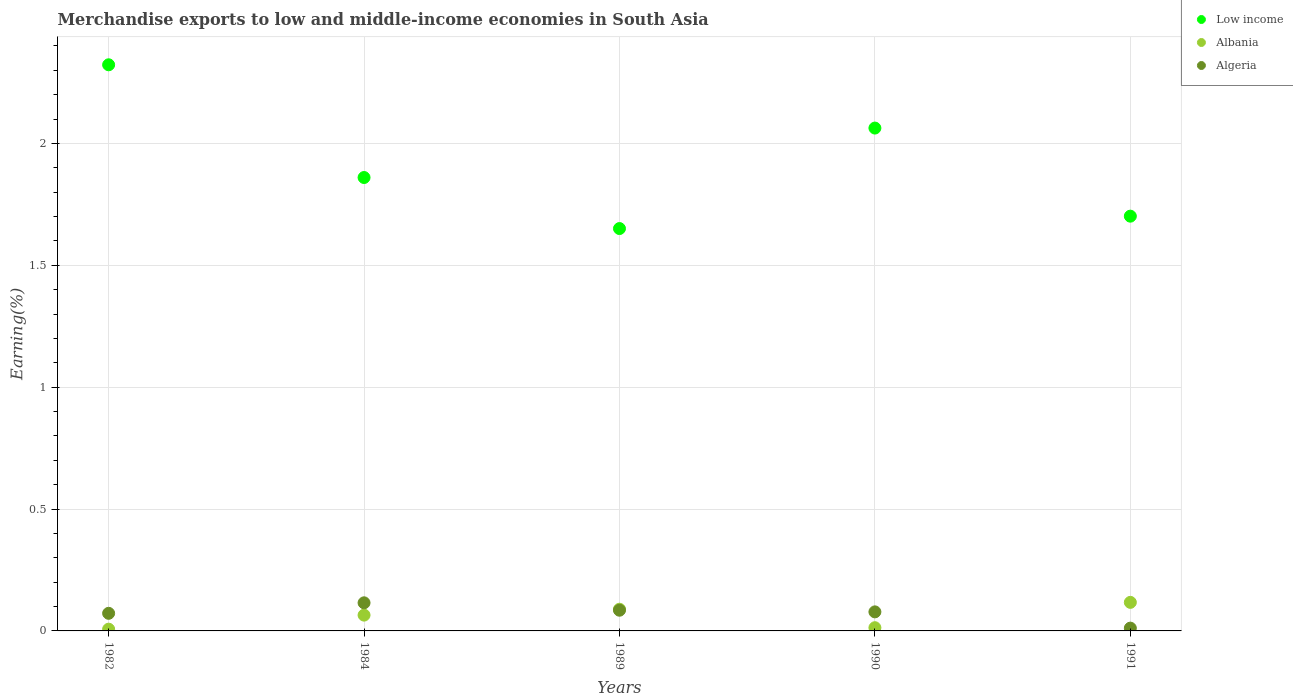How many different coloured dotlines are there?
Offer a very short reply. 3. Is the number of dotlines equal to the number of legend labels?
Make the answer very short. Yes. What is the percentage of amount earned from merchandise exports in Algeria in 1982?
Your response must be concise. 0.07. Across all years, what is the maximum percentage of amount earned from merchandise exports in Low income?
Provide a short and direct response. 2.32. Across all years, what is the minimum percentage of amount earned from merchandise exports in Albania?
Provide a succinct answer. 0.01. In which year was the percentage of amount earned from merchandise exports in Low income minimum?
Your answer should be compact. 1989. What is the total percentage of amount earned from merchandise exports in Albania in the graph?
Keep it short and to the point. 0.29. What is the difference between the percentage of amount earned from merchandise exports in Albania in 1989 and that in 1991?
Provide a short and direct response. -0.03. What is the difference between the percentage of amount earned from merchandise exports in Algeria in 1990 and the percentage of amount earned from merchandise exports in Albania in 1982?
Offer a very short reply. 0.07. What is the average percentage of amount earned from merchandise exports in Algeria per year?
Provide a short and direct response. 0.07. In the year 1984, what is the difference between the percentage of amount earned from merchandise exports in Low income and percentage of amount earned from merchandise exports in Albania?
Your response must be concise. 1.8. In how many years, is the percentage of amount earned from merchandise exports in Algeria greater than 0.5 %?
Provide a short and direct response. 0. What is the ratio of the percentage of amount earned from merchandise exports in Albania in 1984 to that in 1991?
Offer a terse response. 0.55. Is the percentage of amount earned from merchandise exports in Albania in 1982 less than that in 1984?
Provide a succinct answer. Yes. Is the difference between the percentage of amount earned from merchandise exports in Low income in 1984 and 1991 greater than the difference between the percentage of amount earned from merchandise exports in Albania in 1984 and 1991?
Ensure brevity in your answer.  Yes. What is the difference between the highest and the second highest percentage of amount earned from merchandise exports in Low income?
Ensure brevity in your answer.  0.26. What is the difference between the highest and the lowest percentage of amount earned from merchandise exports in Low income?
Your response must be concise. 0.67. Is the sum of the percentage of amount earned from merchandise exports in Albania in 1982 and 1984 greater than the maximum percentage of amount earned from merchandise exports in Algeria across all years?
Your answer should be very brief. No. Is it the case that in every year, the sum of the percentage of amount earned from merchandise exports in Albania and percentage of amount earned from merchandise exports in Algeria  is greater than the percentage of amount earned from merchandise exports in Low income?
Provide a short and direct response. No. How many dotlines are there?
Your answer should be very brief. 3. How many years are there in the graph?
Offer a very short reply. 5. What is the difference between two consecutive major ticks on the Y-axis?
Make the answer very short. 0.5. Does the graph contain grids?
Keep it short and to the point. Yes. Where does the legend appear in the graph?
Make the answer very short. Top right. How many legend labels are there?
Your answer should be very brief. 3. How are the legend labels stacked?
Give a very brief answer. Vertical. What is the title of the graph?
Your response must be concise. Merchandise exports to low and middle-income economies in South Asia. Does "Lower middle income" appear as one of the legend labels in the graph?
Provide a succinct answer. No. What is the label or title of the Y-axis?
Give a very brief answer. Earning(%). What is the Earning(%) in Low income in 1982?
Your response must be concise. 2.32. What is the Earning(%) of Albania in 1982?
Give a very brief answer. 0.01. What is the Earning(%) of Algeria in 1982?
Make the answer very short. 0.07. What is the Earning(%) of Low income in 1984?
Offer a terse response. 1.86. What is the Earning(%) of Albania in 1984?
Make the answer very short. 0.06. What is the Earning(%) of Algeria in 1984?
Your answer should be very brief. 0.12. What is the Earning(%) of Low income in 1989?
Provide a succinct answer. 1.65. What is the Earning(%) of Albania in 1989?
Your answer should be compact. 0.09. What is the Earning(%) of Algeria in 1989?
Keep it short and to the point. 0.08. What is the Earning(%) of Low income in 1990?
Your answer should be very brief. 2.06. What is the Earning(%) of Albania in 1990?
Your answer should be compact. 0.01. What is the Earning(%) in Algeria in 1990?
Offer a very short reply. 0.08. What is the Earning(%) of Low income in 1991?
Ensure brevity in your answer.  1.7. What is the Earning(%) of Albania in 1991?
Offer a terse response. 0.12. What is the Earning(%) of Algeria in 1991?
Your response must be concise. 0.01. Across all years, what is the maximum Earning(%) in Low income?
Keep it short and to the point. 2.32. Across all years, what is the maximum Earning(%) of Albania?
Your response must be concise. 0.12. Across all years, what is the maximum Earning(%) of Algeria?
Your response must be concise. 0.12. Across all years, what is the minimum Earning(%) in Low income?
Give a very brief answer. 1.65. Across all years, what is the minimum Earning(%) of Albania?
Ensure brevity in your answer.  0.01. Across all years, what is the minimum Earning(%) of Algeria?
Offer a terse response. 0.01. What is the total Earning(%) in Low income in the graph?
Give a very brief answer. 9.6. What is the total Earning(%) in Albania in the graph?
Provide a short and direct response. 0.29. What is the total Earning(%) of Algeria in the graph?
Your response must be concise. 0.36. What is the difference between the Earning(%) of Low income in 1982 and that in 1984?
Your answer should be very brief. 0.46. What is the difference between the Earning(%) of Albania in 1982 and that in 1984?
Offer a terse response. -0.06. What is the difference between the Earning(%) in Algeria in 1982 and that in 1984?
Provide a short and direct response. -0.04. What is the difference between the Earning(%) of Low income in 1982 and that in 1989?
Offer a very short reply. 0.67. What is the difference between the Earning(%) in Albania in 1982 and that in 1989?
Provide a succinct answer. -0.08. What is the difference between the Earning(%) in Algeria in 1982 and that in 1989?
Offer a terse response. -0.01. What is the difference between the Earning(%) in Low income in 1982 and that in 1990?
Offer a terse response. 0.26. What is the difference between the Earning(%) of Albania in 1982 and that in 1990?
Offer a very short reply. -0.01. What is the difference between the Earning(%) in Algeria in 1982 and that in 1990?
Your response must be concise. -0.01. What is the difference between the Earning(%) of Low income in 1982 and that in 1991?
Keep it short and to the point. 0.62. What is the difference between the Earning(%) in Albania in 1982 and that in 1991?
Provide a succinct answer. -0.11. What is the difference between the Earning(%) in Algeria in 1982 and that in 1991?
Keep it short and to the point. 0.06. What is the difference between the Earning(%) in Low income in 1984 and that in 1989?
Make the answer very short. 0.21. What is the difference between the Earning(%) in Albania in 1984 and that in 1989?
Provide a short and direct response. -0.02. What is the difference between the Earning(%) of Algeria in 1984 and that in 1989?
Offer a terse response. 0.03. What is the difference between the Earning(%) of Low income in 1984 and that in 1990?
Your answer should be compact. -0.2. What is the difference between the Earning(%) in Albania in 1984 and that in 1990?
Provide a short and direct response. 0.05. What is the difference between the Earning(%) in Algeria in 1984 and that in 1990?
Offer a terse response. 0.04. What is the difference between the Earning(%) in Low income in 1984 and that in 1991?
Offer a terse response. 0.16. What is the difference between the Earning(%) of Albania in 1984 and that in 1991?
Offer a very short reply. -0.05. What is the difference between the Earning(%) of Algeria in 1984 and that in 1991?
Your response must be concise. 0.1. What is the difference between the Earning(%) of Low income in 1989 and that in 1990?
Ensure brevity in your answer.  -0.41. What is the difference between the Earning(%) of Albania in 1989 and that in 1990?
Your response must be concise. 0.08. What is the difference between the Earning(%) in Algeria in 1989 and that in 1990?
Provide a short and direct response. 0.01. What is the difference between the Earning(%) of Low income in 1989 and that in 1991?
Provide a short and direct response. -0.05. What is the difference between the Earning(%) of Albania in 1989 and that in 1991?
Give a very brief answer. -0.03. What is the difference between the Earning(%) of Algeria in 1989 and that in 1991?
Your answer should be compact. 0.07. What is the difference between the Earning(%) of Low income in 1990 and that in 1991?
Provide a succinct answer. 0.36. What is the difference between the Earning(%) of Albania in 1990 and that in 1991?
Give a very brief answer. -0.1. What is the difference between the Earning(%) of Algeria in 1990 and that in 1991?
Ensure brevity in your answer.  0.07. What is the difference between the Earning(%) of Low income in 1982 and the Earning(%) of Albania in 1984?
Ensure brevity in your answer.  2.26. What is the difference between the Earning(%) in Low income in 1982 and the Earning(%) in Algeria in 1984?
Give a very brief answer. 2.21. What is the difference between the Earning(%) of Albania in 1982 and the Earning(%) of Algeria in 1984?
Provide a succinct answer. -0.11. What is the difference between the Earning(%) in Low income in 1982 and the Earning(%) in Albania in 1989?
Offer a terse response. 2.23. What is the difference between the Earning(%) in Low income in 1982 and the Earning(%) in Algeria in 1989?
Keep it short and to the point. 2.24. What is the difference between the Earning(%) of Albania in 1982 and the Earning(%) of Algeria in 1989?
Provide a succinct answer. -0.08. What is the difference between the Earning(%) of Low income in 1982 and the Earning(%) of Albania in 1990?
Ensure brevity in your answer.  2.31. What is the difference between the Earning(%) of Low income in 1982 and the Earning(%) of Algeria in 1990?
Your response must be concise. 2.24. What is the difference between the Earning(%) in Albania in 1982 and the Earning(%) in Algeria in 1990?
Give a very brief answer. -0.07. What is the difference between the Earning(%) of Low income in 1982 and the Earning(%) of Albania in 1991?
Make the answer very short. 2.21. What is the difference between the Earning(%) of Low income in 1982 and the Earning(%) of Algeria in 1991?
Your answer should be very brief. 2.31. What is the difference between the Earning(%) of Albania in 1982 and the Earning(%) of Algeria in 1991?
Offer a very short reply. -0. What is the difference between the Earning(%) in Low income in 1984 and the Earning(%) in Albania in 1989?
Ensure brevity in your answer.  1.77. What is the difference between the Earning(%) in Low income in 1984 and the Earning(%) in Algeria in 1989?
Ensure brevity in your answer.  1.78. What is the difference between the Earning(%) of Albania in 1984 and the Earning(%) of Algeria in 1989?
Your answer should be very brief. -0.02. What is the difference between the Earning(%) of Low income in 1984 and the Earning(%) of Albania in 1990?
Provide a succinct answer. 1.85. What is the difference between the Earning(%) in Low income in 1984 and the Earning(%) in Algeria in 1990?
Offer a terse response. 1.78. What is the difference between the Earning(%) in Albania in 1984 and the Earning(%) in Algeria in 1990?
Your answer should be very brief. -0.01. What is the difference between the Earning(%) of Low income in 1984 and the Earning(%) of Albania in 1991?
Give a very brief answer. 1.74. What is the difference between the Earning(%) in Low income in 1984 and the Earning(%) in Algeria in 1991?
Your response must be concise. 1.85. What is the difference between the Earning(%) of Albania in 1984 and the Earning(%) of Algeria in 1991?
Offer a very short reply. 0.05. What is the difference between the Earning(%) in Low income in 1989 and the Earning(%) in Albania in 1990?
Your answer should be very brief. 1.64. What is the difference between the Earning(%) in Low income in 1989 and the Earning(%) in Algeria in 1990?
Your response must be concise. 1.57. What is the difference between the Earning(%) of Albania in 1989 and the Earning(%) of Algeria in 1990?
Offer a terse response. 0.01. What is the difference between the Earning(%) in Low income in 1989 and the Earning(%) in Albania in 1991?
Ensure brevity in your answer.  1.53. What is the difference between the Earning(%) in Low income in 1989 and the Earning(%) in Algeria in 1991?
Your answer should be compact. 1.64. What is the difference between the Earning(%) in Albania in 1989 and the Earning(%) in Algeria in 1991?
Provide a succinct answer. 0.08. What is the difference between the Earning(%) of Low income in 1990 and the Earning(%) of Albania in 1991?
Offer a very short reply. 1.95. What is the difference between the Earning(%) in Low income in 1990 and the Earning(%) in Algeria in 1991?
Offer a terse response. 2.05. What is the difference between the Earning(%) of Albania in 1990 and the Earning(%) of Algeria in 1991?
Ensure brevity in your answer.  0. What is the average Earning(%) in Low income per year?
Provide a succinct answer. 1.92. What is the average Earning(%) in Albania per year?
Make the answer very short. 0.06. What is the average Earning(%) in Algeria per year?
Your response must be concise. 0.07. In the year 1982, what is the difference between the Earning(%) of Low income and Earning(%) of Albania?
Offer a terse response. 2.32. In the year 1982, what is the difference between the Earning(%) of Low income and Earning(%) of Algeria?
Your answer should be very brief. 2.25. In the year 1982, what is the difference between the Earning(%) in Albania and Earning(%) in Algeria?
Provide a short and direct response. -0.07. In the year 1984, what is the difference between the Earning(%) of Low income and Earning(%) of Albania?
Ensure brevity in your answer.  1.8. In the year 1984, what is the difference between the Earning(%) in Low income and Earning(%) in Algeria?
Provide a short and direct response. 1.74. In the year 1984, what is the difference between the Earning(%) of Albania and Earning(%) of Algeria?
Make the answer very short. -0.05. In the year 1989, what is the difference between the Earning(%) of Low income and Earning(%) of Albania?
Your answer should be very brief. 1.56. In the year 1989, what is the difference between the Earning(%) in Low income and Earning(%) in Algeria?
Your answer should be very brief. 1.57. In the year 1989, what is the difference between the Earning(%) in Albania and Earning(%) in Algeria?
Keep it short and to the point. 0. In the year 1990, what is the difference between the Earning(%) in Low income and Earning(%) in Albania?
Make the answer very short. 2.05. In the year 1990, what is the difference between the Earning(%) of Low income and Earning(%) of Algeria?
Provide a short and direct response. 1.98. In the year 1990, what is the difference between the Earning(%) in Albania and Earning(%) in Algeria?
Offer a very short reply. -0.07. In the year 1991, what is the difference between the Earning(%) of Low income and Earning(%) of Albania?
Your response must be concise. 1.58. In the year 1991, what is the difference between the Earning(%) in Low income and Earning(%) in Algeria?
Your answer should be compact. 1.69. In the year 1991, what is the difference between the Earning(%) of Albania and Earning(%) of Algeria?
Keep it short and to the point. 0.11. What is the ratio of the Earning(%) in Low income in 1982 to that in 1984?
Your response must be concise. 1.25. What is the ratio of the Earning(%) in Albania in 1982 to that in 1984?
Provide a succinct answer. 0.11. What is the ratio of the Earning(%) of Algeria in 1982 to that in 1984?
Your answer should be very brief. 0.63. What is the ratio of the Earning(%) of Low income in 1982 to that in 1989?
Ensure brevity in your answer.  1.41. What is the ratio of the Earning(%) of Albania in 1982 to that in 1989?
Give a very brief answer. 0.08. What is the ratio of the Earning(%) of Algeria in 1982 to that in 1989?
Your answer should be compact. 0.85. What is the ratio of the Earning(%) of Low income in 1982 to that in 1990?
Offer a terse response. 1.13. What is the ratio of the Earning(%) of Albania in 1982 to that in 1990?
Provide a short and direct response. 0.54. What is the ratio of the Earning(%) in Algeria in 1982 to that in 1990?
Your answer should be compact. 0.92. What is the ratio of the Earning(%) of Low income in 1982 to that in 1991?
Provide a succinct answer. 1.36. What is the ratio of the Earning(%) of Albania in 1982 to that in 1991?
Provide a short and direct response. 0.06. What is the ratio of the Earning(%) in Algeria in 1982 to that in 1991?
Your answer should be very brief. 6.31. What is the ratio of the Earning(%) in Low income in 1984 to that in 1989?
Your response must be concise. 1.13. What is the ratio of the Earning(%) of Albania in 1984 to that in 1989?
Your answer should be very brief. 0.73. What is the ratio of the Earning(%) of Algeria in 1984 to that in 1989?
Offer a very short reply. 1.36. What is the ratio of the Earning(%) of Low income in 1984 to that in 1990?
Provide a succinct answer. 0.9. What is the ratio of the Earning(%) in Albania in 1984 to that in 1990?
Your response must be concise. 4.91. What is the ratio of the Earning(%) in Algeria in 1984 to that in 1990?
Provide a succinct answer. 1.48. What is the ratio of the Earning(%) in Low income in 1984 to that in 1991?
Your response must be concise. 1.09. What is the ratio of the Earning(%) of Albania in 1984 to that in 1991?
Offer a terse response. 0.55. What is the ratio of the Earning(%) of Algeria in 1984 to that in 1991?
Provide a short and direct response. 10.07. What is the ratio of the Earning(%) of Low income in 1989 to that in 1990?
Offer a very short reply. 0.8. What is the ratio of the Earning(%) of Albania in 1989 to that in 1990?
Offer a very short reply. 6.74. What is the ratio of the Earning(%) in Algeria in 1989 to that in 1990?
Your response must be concise. 1.09. What is the ratio of the Earning(%) in Low income in 1989 to that in 1991?
Give a very brief answer. 0.97. What is the ratio of the Earning(%) in Albania in 1989 to that in 1991?
Keep it short and to the point. 0.76. What is the ratio of the Earning(%) in Algeria in 1989 to that in 1991?
Give a very brief answer. 7.42. What is the ratio of the Earning(%) in Low income in 1990 to that in 1991?
Offer a very short reply. 1.21. What is the ratio of the Earning(%) in Albania in 1990 to that in 1991?
Ensure brevity in your answer.  0.11. What is the ratio of the Earning(%) of Algeria in 1990 to that in 1991?
Give a very brief answer. 6.83. What is the difference between the highest and the second highest Earning(%) of Low income?
Your answer should be compact. 0.26. What is the difference between the highest and the second highest Earning(%) of Albania?
Ensure brevity in your answer.  0.03. What is the difference between the highest and the second highest Earning(%) in Algeria?
Offer a terse response. 0.03. What is the difference between the highest and the lowest Earning(%) in Low income?
Keep it short and to the point. 0.67. What is the difference between the highest and the lowest Earning(%) in Albania?
Provide a succinct answer. 0.11. What is the difference between the highest and the lowest Earning(%) in Algeria?
Make the answer very short. 0.1. 